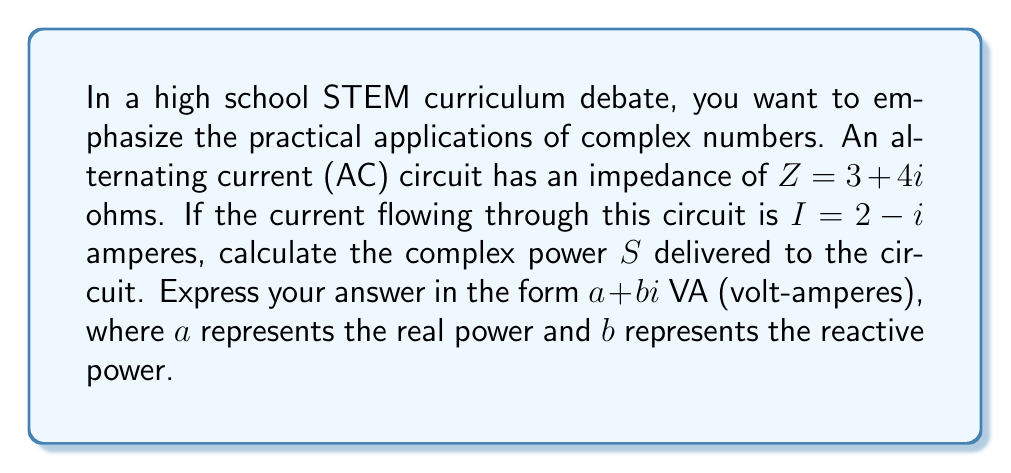Could you help me with this problem? To solve this problem, we'll follow these steps:

1) The complex power $S$ in an AC circuit is given by the formula:

   $$S = I^2 \cdot Z^*$$

   Where $I$ is the current, $Z$ is the impedance, and $Z^*$ is the complex conjugate of $Z$.

2) We're given:
   $Z = 3 + 4i$ ohms
   $I = 2 - i$ amperes

3) First, let's find $Z^*$:
   $Z^* = 3 - 4i$

4) Now, we need to calculate $I^2$:
   $$I^2 = (2-i)^2 = 4 - 4i + i^2 = 4 - 4i - 1 = 3 - 4i$$

5) Now we can multiply $I^2$ by $Z^*$:

   $$S = (3 - 4i)(3 - 4i)$$

6) Let's multiply these complex numbers:
   $$(3 - 4i)(3 - 4i) = 9 - 12i - 12i + 16i^2$$
   $$= 9 - 24i + 16(-1)$$
   $$= -7 - 24i$$

7) Therefore, the complex power $S = -7 - 24i$ VA.

The real part (-7) represents the real power in watts (W), and the imaginary part (-24) represents the reactive power in volt-amperes reactive (VAR).
Answer: $S = -7 - 24i$ VA 